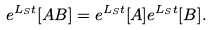Convert formula to latex. <formula><loc_0><loc_0><loc_500><loc_500>e ^ { L _ { S } t } [ A B ] = e ^ { L _ { S } t } [ A ] e ^ { L _ { S } t } [ B ] .</formula> 